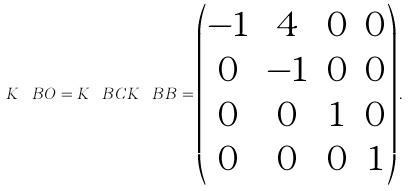<formula> <loc_0><loc_0><loc_500><loc_500>K _ { \ } B O = K _ { \ } B C K _ { \ } B B = \begin{pmatrix} - 1 & 4 & 0 & 0 \\ 0 & - 1 & 0 & 0 \\ 0 & 0 & 1 & 0 \\ 0 & 0 & 0 & 1 \end{pmatrix} .</formula> 